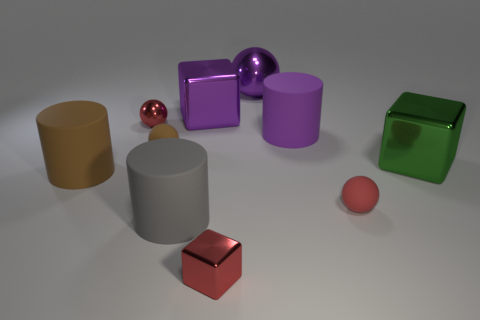There is a brown ball that is made of the same material as the gray object; what size is it?
Give a very brief answer. Small. What number of red things have the same shape as the large gray matte thing?
Provide a short and direct response. 0. How many large green metal blocks are there?
Offer a terse response. 1. There is a tiny object that is in front of the gray matte cylinder; is it the same shape as the large brown matte object?
Provide a succinct answer. No. Are there the same number of blocks and gray matte objects?
Ensure brevity in your answer.  No. What is the material of the brown thing that is the same size as the purple cylinder?
Provide a short and direct response. Rubber. Are there any large gray cylinders that have the same material as the red block?
Offer a very short reply. No. Does the red matte thing have the same shape as the large purple metal object to the left of the tiny cube?
Offer a very short reply. No. How many shiny cubes are behind the green thing and in front of the purple block?
Keep it short and to the point. 0. Is the material of the green block the same as the red sphere in front of the large purple rubber cylinder?
Give a very brief answer. No. 